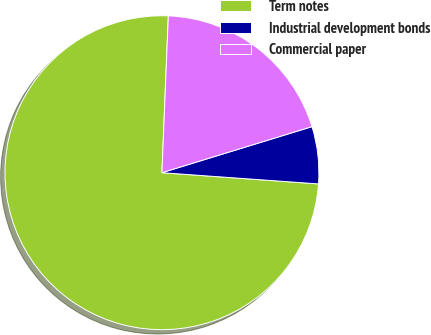Convert chart. <chart><loc_0><loc_0><loc_500><loc_500><pie_chart><fcel>Term notes<fcel>Industrial development bonds<fcel>Commercial paper<nl><fcel>74.51%<fcel>5.88%<fcel>19.61%<nl></chart> 